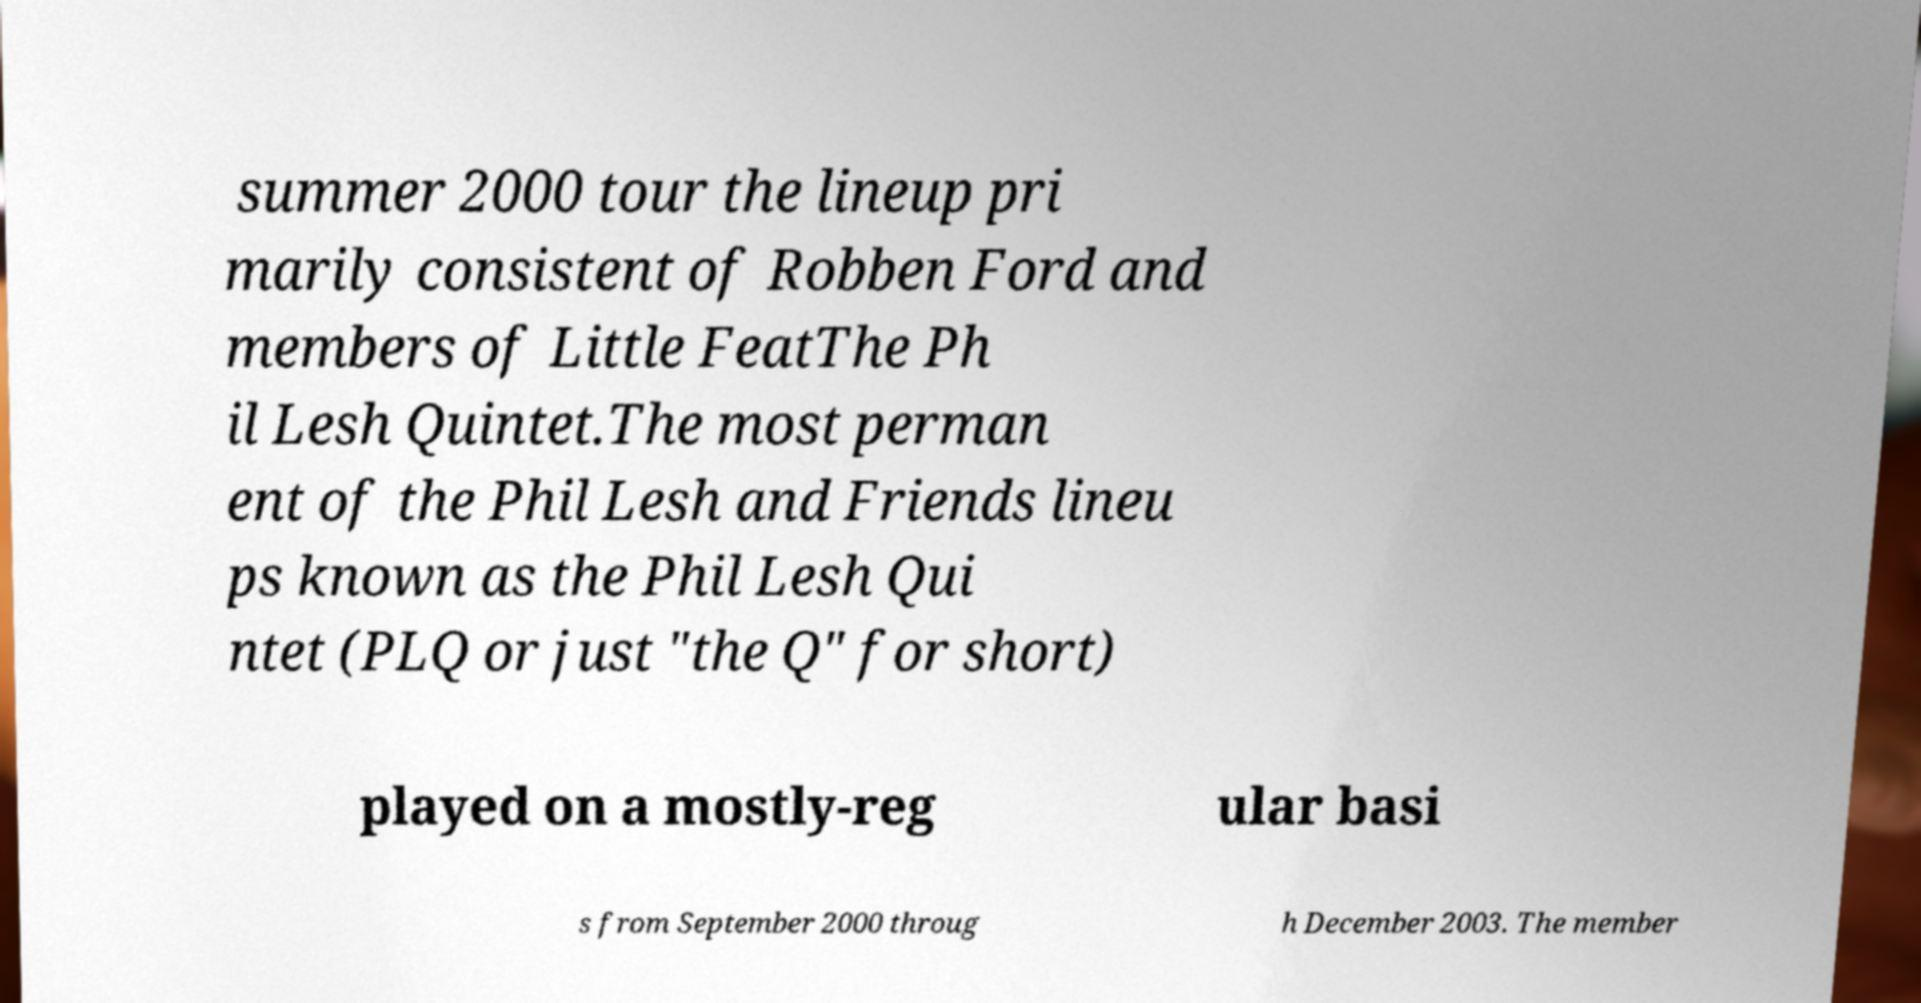Could you assist in decoding the text presented in this image and type it out clearly? summer 2000 tour the lineup pri marily consistent of Robben Ford and members of Little FeatThe Ph il Lesh Quintet.The most perman ent of the Phil Lesh and Friends lineu ps known as the Phil Lesh Qui ntet (PLQ or just "the Q" for short) played on a mostly-reg ular basi s from September 2000 throug h December 2003. The member 